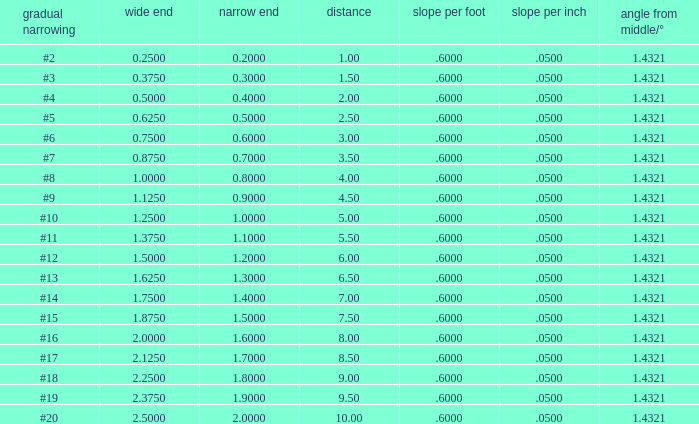Which Angle from center/° has a Taper/ft smaller than 0.6000000000000001? 19.0. 